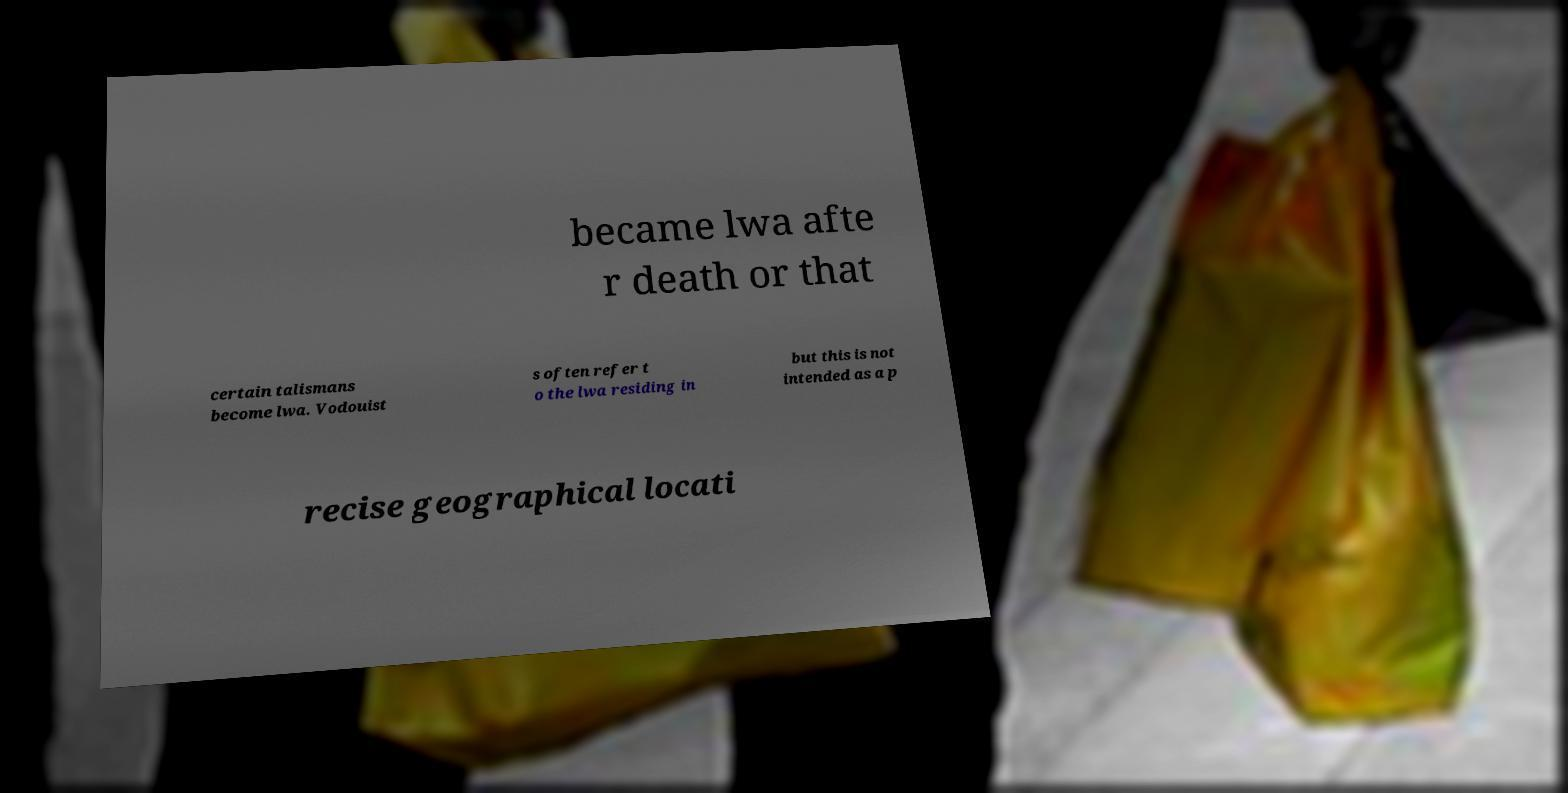Can you read and provide the text displayed in the image?This photo seems to have some interesting text. Can you extract and type it out for me? became lwa afte r death or that certain talismans become lwa. Vodouist s often refer t o the lwa residing in but this is not intended as a p recise geographical locati 